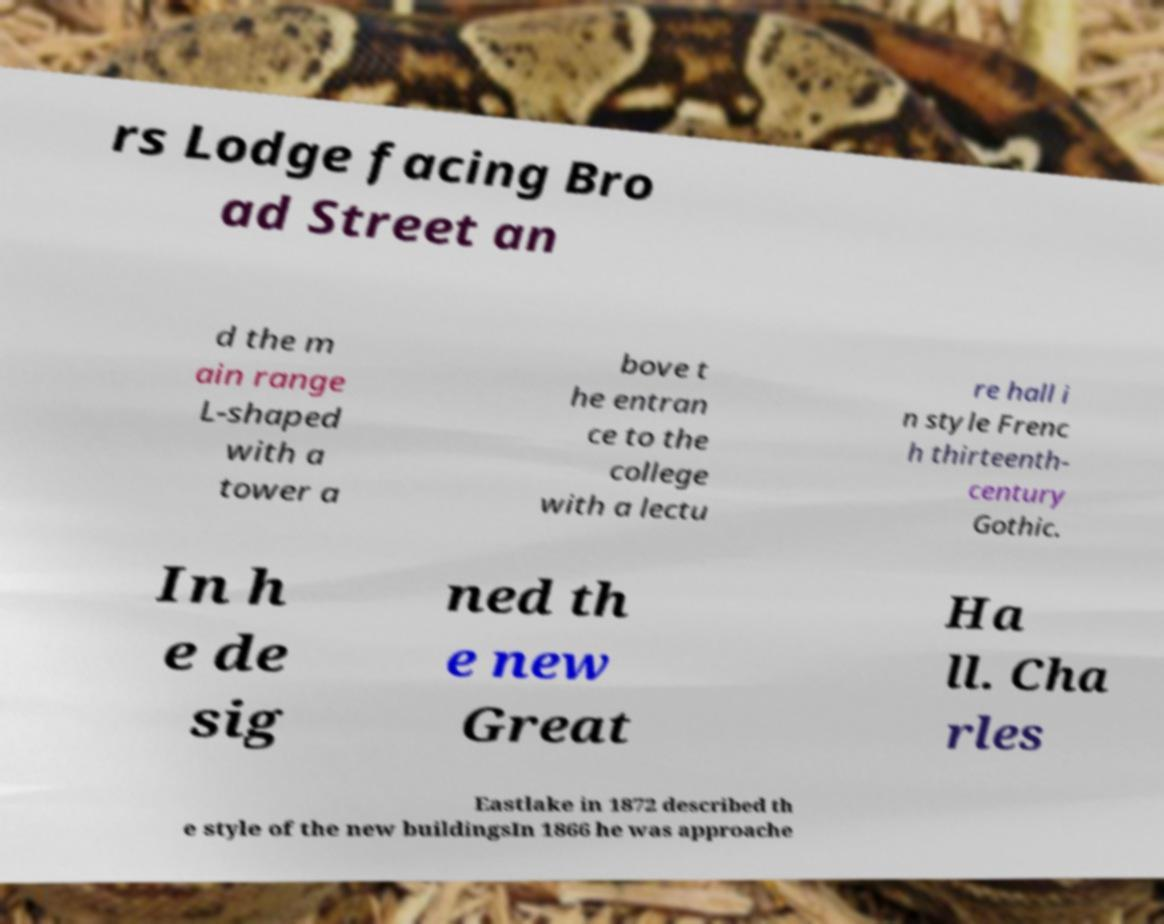Can you read and provide the text displayed in the image?This photo seems to have some interesting text. Can you extract and type it out for me? rs Lodge facing Bro ad Street an d the m ain range L-shaped with a tower a bove t he entran ce to the college with a lectu re hall i n style Frenc h thirteenth- century Gothic. In h e de sig ned th e new Great Ha ll. Cha rles Eastlake in 1872 described th e style of the new buildingsIn 1866 he was approache 